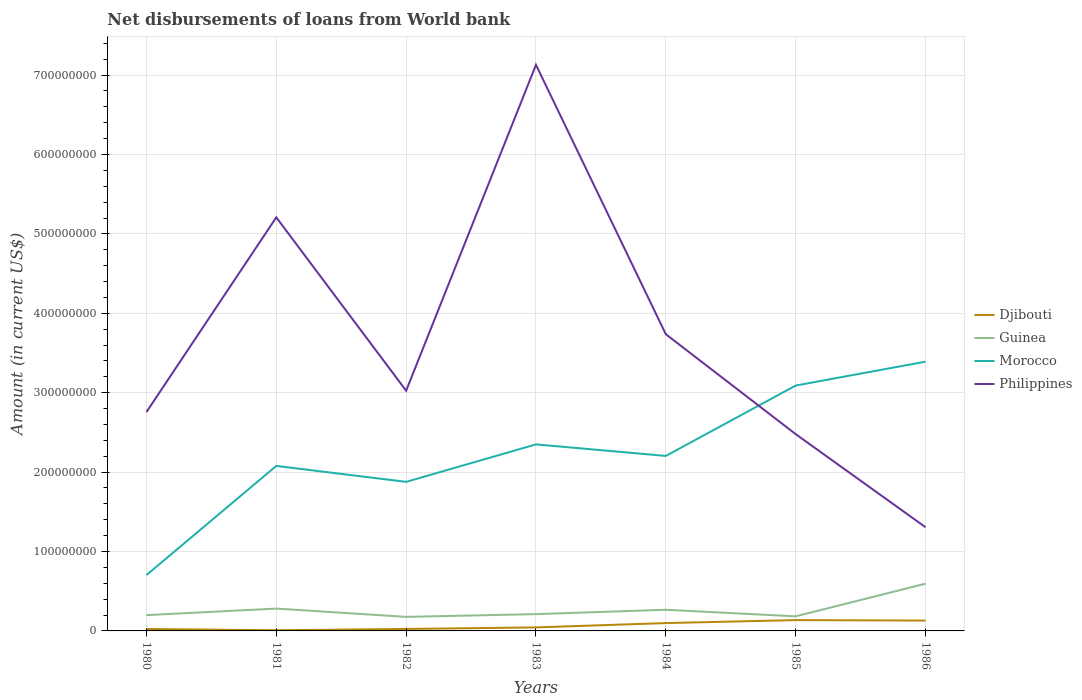How many different coloured lines are there?
Your response must be concise. 4. Is the number of lines equal to the number of legend labels?
Provide a succinct answer. Yes. Across all years, what is the maximum amount of loan disbursed from World Bank in Morocco?
Give a very brief answer. 7.03e+07. What is the total amount of loan disbursed from World Bank in Guinea in the graph?
Ensure brevity in your answer.  2.80e+06. What is the difference between the highest and the second highest amount of loan disbursed from World Bank in Djibouti?
Provide a short and direct response. 1.28e+07. What is the difference between the highest and the lowest amount of loan disbursed from World Bank in Philippines?
Offer a very short reply. 3. Is the amount of loan disbursed from World Bank in Philippines strictly greater than the amount of loan disbursed from World Bank in Guinea over the years?
Your response must be concise. No. How many years are there in the graph?
Make the answer very short. 7. What is the difference between two consecutive major ticks on the Y-axis?
Your response must be concise. 1.00e+08. Are the values on the major ticks of Y-axis written in scientific E-notation?
Your answer should be very brief. No. Does the graph contain any zero values?
Keep it short and to the point. No. Does the graph contain grids?
Ensure brevity in your answer.  Yes. Where does the legend appear in the graph?
Ensure brevity in your answer.  Center right. How many legend labels are there?
Your response must be concise. 4. How are the legend labels stacked?
Keep it short and to the point. Vertical. What is the title of the graph?
Keep it short and to the point. Net disbursements of loans from World bank. What is the Amount (in current US$) of Djibouti in 1980?
Make the answer very short. 2.40e+06. What is the Amount (in current US$) in Guinea in 1980?
Your answer should be very brief. 1.99e+07. What is the Amount (in current US$) in Morocco in 1980?
Offer a terse response. 7.03e+07. What is the Amount (in current US$) of Philippines in 1980?
Keep it short and to the point. 2.76e+08. What is the Amount (in current US$) of Djibouti in 1981?
Provide a succinct answer. 8.20e+05. What is the Amount (in current US$) of Guinea in 1981?
Your answer should be compact. 2.81e+07. What is the Amount (in current US$) in Morocco in 1981?
Make the answer very short. 2.08e+08. What is the Amount (in current US$) in Philippines in 1981?
Your answer should be very brief. 5.21e+08. What is the Amount (in current US$) of Djibouti in 1982?
Your response must be concise. 2.48e+06. What is the Amount (in current US$) of Guinea in 1982?
Keep it short and to the point. 1.77e+07. What is the Amount (in current US$) in Morocco in 1982?
Provide a short and direct response. 1.88e+08. What is the Amount (in current US$) of Philippines in 1982?
Offer a terse response. 3.03e+08. What is the Amount (in current US$) of Djibouti in 1983?
Your answer should be compact. 4.42e+06. What is the Amount (in current US$) in Guinea in 1983?
Offer a terse response. 2.11e+07. What is the Amount (in current US$) in Morocco in 1983?
Your answer should be compact. 2.35e+08. What is the Amount (in current US$) of Philippines in 1983?
Provide a succinct answer. 7.13e+08. What is the Amount (in current US$) in Djibouti in 1984?
Provide a succinct answer. 9.88e+06. What is the Amount (in current US$) of Guinea in 1984?
Provide a succinct answer. 2.66e+07. What is the Amount (in current US$) of Morocco in 1984?
Keep it short and to the point. 2.20e+08. What is the Amount (in current US$) in Philippines in 1984?
Provide a short and direct response. 3.74e+08. What is the Amount (in current US$) of Djibouti in 1985?
Ensure brevity in your answer.  1.36e+07. What is the Amount (in current US$) of Guinea in 1985?
Keep it short and to the point. 1.84e+07. What is the Amount (in current US$) of Morocco in 1985?
Your response must be concise. 3.09e+08. What is the Amount (in current US$) of Philippines in 1985?
Your answer should be very brief. 2.48e+08. What is the Amount (in current US$) in Djibouti in 1986?
Keep it short and to the point. 1.30e+07. What is the Amount (in current US$) of Guinea in 1986?
Ensure brevity in your answer.  5.95e+07. What is the Amount (in current US$) in Morocco in 1986?
Give a very brief answer. 3.39e+08. What is the Amount (in current US$) in Philippines in 1986?
Offer a very short reply. 1.31e+08. Across all years, what is the maximum Amount (in current US$) of Djibouti?
Offer a very short reply. 1.36e+07. Across all years, what is the maximum Amount (in current US$) of Guinea?
Your answer should be very brief. 5.95e+07. Across all years, what is the maximum Amount (in current US$) of Morocco?
Offer a very short reply. 3.39e+08. Across all years, what is the maximum Amount (in current US$) in Philippines?
Your answer should be compact. 7.13e+08. Across all years, what is the minimum Amount (in current US$) in Djibouti?
Ensure brevity in your answer.  8.20e+05. Across all years, what is the minimum Amount (in current US$) in Guinea?
Provide a short and direct response. 1.77e+07. Across all years, what is the minimum Amount (in current US$) of Morocco?
Your answer should be very brief. 7.03e+07. Across all years, what is the minimum Amount (in current US$) of Philippines?
Your response must be concise. 1.31e+08. What is the total Amount (in current US$) of Djibouti in the graph?
Your answer should be compact. 4.67e+07. What is the total Amount (in current US$) in Guinea in the graph?
Keep it short and to the point. 1.91e+08. What is the total Amount (in current US$) in Morocco in the graph?
Offer a terse response. 1.57e+09. What is the total Amount (in current US$) in Philippines in the graph?
Provide a short and direct response. 2.56e+09. What is the difference between the Amount (in current US$) of Djibouti in 1980 and that in 1981?
Keep it short and to the point. 1.58e+06. What is the difference between the Amount (in current US$) in Guinea in 1980 and that in 1981?
Your answer should be compact. -8.24e+06. What is the difference between the Amount (in current US$) in Morocco in 1980 and that in 1981?
Keep it short and to the point. -1.37e+08. What is the difference between the Amount (in current US$) of Philippines in 1980 and that in 1981?
Make the answer very short. -2.45e+08. What is the difference between the Amount (in current US$) in Djibouti in 1980 and that in 1982?
Your response must be concise. -8.30e+04. What is the difference between the Amount (in current US$) in Guinea in 1980 and that in 1982?
Your answer should be very brief. 2.21e+06. What is the difference between the Amount (in current US$) of Morocco in 1980 and that in 1982?
Your answer should be very brief. -1.17e+08. What is the difference between the Amount (in current US$) in Philippines in 1980 and that in 1982?
Your answer should be very brief. -2.69e+07. What is the difference between the Amount (in current US$) in Djibouti in 1980 and that in 1983?
Your answer should be compact. -2.02e+06. What is the difference between the Amount (in current US$) in Guinea in 1980 and that in 1983?
Make the answer very short. -1.24e+06. What is the difference between the Amount (in current US$) of Morocco in 1980 and that in 1983?
Your answer should be compact. -1.65e+08. What is the difference between the Amount (in current US$) of Philippines in 1980 and that in 1983?
Give a very brief answer. -4.37e+08. What is the difference between the Amount (in current US$) in Djibouti in 1980 and that in 1984?
Keep it short and to the point. -7.48e+06. What is the difference between the Amount (in current US$) in Guinea in 1980 and that in 1984?
Keep it short and to the point. -6.73e+06. What is the difference between the Amount (in current US$) in Morocco in 1980 and that in 1984?
Your response must be concise. -1.50e+08. What is the difference between the Amount (in current US$) of Philippines in 1980 and that in 1984?
Your answer should be compact. -9.80e+07. What is the difference between the Amount (in current US$) in Djibouti in 1980 and that in 1985?
Offer a very short reply. -1.12e+07. What is the difference between the Amount (in current US$) in Guinea in 1980 and that in 1985?
Provide a short and direct response. 1.55e+06. What is the difference between the Amount (in current US$) in Morocco in 1980 and that in 1985?
Make the answer very short. -2.39e+08. What is the difference between the Amount (in current US$) of Philippines in 1980 and that in 1985?
Keep it short and to the point. 2.78e+07. What is the difference between the Amount (in current US$) of Djibouti in 1980 and that in 1986?
Your answer should be very brief. -1.06e+07. What is the difference between the Amount (in current US$) of Guinea in 1980 and that in 1986?
Keep it short and to the point. -3.96e+07. What is the difference between the Amount (in current US$) in Morocco in 1980 and that in 1986?
Provide a succinct answer. -2.69e+08. What is the difference between the Amount (in current US$) of Philippines in 1980 and that in 1986?
Offer a terse response. 1.45e+08. What is the difference between the Amount (in current US$) in Djibouti in 1981 and that in 1982?
Offer a very short reply. -1.66e+06. What is the difference between the Amount (in current US$) of Guinea in 1981 and that in 1982?
Your answer should be very brief. 1.04e+07. What is the difference between the Amount (in current US$) in Morocco in 1981 and that in 1982?
Provide a succinct answer. 2.01e+07. What is the difference between the Amount (in current US$) of Philippines in 1981 and that in 1982?
Provide a short and direct response. 2.18e+08. What is the difference between the Amount (in current US$) in Djibouti in 1981 and that in 1983?
Your response must be concise. -3.60e+06. What is the difference between the Amount (in current US$) in Guinea in 1981 and that in 1983?
Provide a short and direct response. 7.00e+06. What is the difference between the Amount (in current US$) of Morocco in 1981 and that in 1983?
Ensure brevity in your answer.  -2.71e+07. What is the difference between the Amount (in current US$) in Philippines in 1981 and that in 1983?
Offer a terse response. -1.92e+08. What is the difference between the Amount (in current US$) of Djibouti in 1981 and that in 1984?
Offer a very short reply. -9.06e+06. What is the difference between the Amount (in current US$) of Guinea in 1981 and that in 1984?
Make the answer very short. 1.51e+06. What is the difference between the Amount (in current US$) of Morocco in 1981 and that in 1984?
Your answer should be very brief. -1.26e+07. What is the difference between the Amount (in current US$) of Philippines in 1981 and that in 1984?
Your answer should be compact. 1.47e+08. What is the difference between the Amount (in current US$) in Djibouti in 1981 and that in 1985?
Provide a short and direct response. -1.28e+07. What is the difference between the Amount (in current US$) in Guinea in 1981 and that in 1985?
Give a very brief answer. 9.79e+06. What is the difference between the Amount (in current US$) in Morocco in 1981 and that in 1985?
Offer a terse response. -1.01e+08. What is the difference between the Amount (in current US$) of Philippines in 1981 and that in 1985?
Provide a succinct answer. 2.73e+08. What is the difference between the Amount (in current US$) of Djibouti in 1981 and that in 1986?
Keep it short and to the point. -1.22e+07. What is the difference between the Amount (in current US$) in Guinea in 1981 and that in 1986?
Ensure brevity in your answer.  -3.14e+07. What is the difference between the Amount (in current US$) in Morocco in 1981 and that in 1986?
Your response must be concise. -1.31e+08. What is the difference between the Amount (in current US$) of Philippines in 1981 and that in 1986?
Make the answer very short. 3.90e+08. What is the difference between the Amount (in current US$) in Djibouti in 1982 and that in 1983?
Ensure brevity in your answer.  -1.94e+06. What is the difference between the Amount (in current US$) of Guinea in 1982 and that in 1983?
Provide a succinct answer. -3.45e+06. What is the difference between the Amount (in current US$) in Morocco in 1982 and that in 1983?
Offer a terse response. -4.72e+07. What is the difference between the Amount (in current US$) of Philippines in 1982 and that in 1983?
Keep it short and to the point. -4.10e+08. What is the difference between the Amount (in current US$) in Djibouti in 1982 and that in 1984?
Make the answer very short. -7.40e+06. What is the difference between the Amount (in current US$) of Guinea in 1982 and that in 1984?
Your answer should be compact. -8.94e+06. What is the difference between the Amount (in current US$) in Morocco in 1982 and that in 1984?
Make the answer very short. -3.27e+07. What is the difference between the Amount (in current US$) of Philippines in 1982 and that in 1984?
Provide a succinct answer. -7.11e+07. What is the difference between the Amount (in current US$) of Djibouti in 1982 and that in 1985?
Provide a short and direct response. -1.11e+07. What is the difference between the Amount (in current US$) in Guinea in 1982 and that in 1985?
Offer a very short reply. -6.57e+05. What is the difference between the Amount (in current US$) of Morocco in 1982 and that in 1985?
Provide a succinct answer. -1.21e+08. What is the difference between the Amount (in current US$) in Philippines in 1982 and that in 1985?
Ensure brevity in your answer.  5.47e+07. What is the difference between the Amount (in current US$) of Djibouti in 1982 and that in 1986?
Ensure brevity in your answer.  -1.06e+07. What is the difference between the Amount (in current US$) of Guinea in 1982 and that in 1986?
Ensure brevity in your answer.  -4.18e+07. What is the difference between the Amount (in current US$) in Morocco in 1982 and that in 1986?
Your response must be concise. -1.51e+08. What is the difference between the Amount (in current US$) of Philippines in 1982 and that in 1986?
Provide a short and direct response. 1.72e+08. What is the difference between the Amount (in current US$) of Djibouti in 1983 and that in 1984?
Provide a short and direct response. -5.46e+06. What is the difference between the Amount (in current US$) in Guinea in 1983 and that in 1984?
Your response must be concise. -5.49e+06. What is the difference between the Amount (in current US$) in Morocco in 1983 and that in 1984?
Offer a very short reply. 1.45e+07. What is the difference between the Amount (in current US$) in Philippines in 1983 and that in 1984?
Offer a very short reply. 3.39e+08. What is the difference between the Amount (in current US$) of Djibouti in 1983 and that in 1985?
Your response must be concise. -9.21e+06. What is the difference between the Amount (in current US$) in Guinea in 1983 and that in 1985?
Ensure brevity in your answer.  2.80e+06. What is the difference between the Amount (in current US$) of Morocco in 1983 and that in 1985?
Give a very brief answer. -7.41e+07. What is the difference between the Amount (in current US$) of Philippines in 1983 and that in 1985?
Make the answer very short. 4.65e+08. What is the difference between the Amount (in current US$) in Djibouti in 1983 and that in 1986?
Your answer should be compact. -8.62e+06. What is the difference between the Amount (in current US$) of Guinea in 1983 and that in 1986?
Give a very brief answer. -3.84e+07. What is the difference between the Amount (in current US$) of Morocco in 1983 and that in 1986?
Keep it short and to the point. -1.04e+08. What is the difference between the Amount (in current US$) in Philippines in 1983 and that in 1986?
Provide a succinct answer. 5.82e+08. What is the difference between the Amount (in current US$) of Djibouti in 1984 and that in 1985?
Your answer should be compact. -3.75e+06. What is the difference between the Amount (in current US$) in Guinea in 1984 and that in 1985?
Your response must be concise. 8.29e+06. What is the difference between the Amount (in current US$) in Morocco in 1984 and that in 1985?
Your answer should be very brief. -8.86e+07. What is the difference between the Amount (in current US$) in Philippines in 1984 and that in 1985?
Your answer should be compact. 1.26e+08. What is the difference between the Amount (in current US$) in Djibouti in 1984 and that in 1986?
Ensure brevity in your answer.  -3.16e+06. What is the difference between the Amount (in current US$) of Guinea in 1984 and that in 1986?
Your response must be concise. -3.29e+07. What is the difference between the Amount (in current US$) of Morocco in 1984 and that in 1986?
Your response must be concise. -1.19e+08. What is the difference between the Amount (in current US$) in Philippines in 1984 and that in 1986?
Your answer should be very brief. 2.43e+08. What is the difference between the Amount (in current US$) in Djibouti in 1985 and that in 1986?
Your answer should be very brief. 5.93e+05. What is the difference between the Amount (in current US$) of Guinea in 1985 and that in 1986?
Keep it short and to the point. -4.12e+07. What is the difference between the Amount (in current US$) of Morocco in 1985 and that in 1986?
Ensure brevity in your answer.  -3.01e+07. What is the difference between the Amount (in current US$) of Philippines in 1985 and that in 1986?
Provide a succinct answer. 1.17e+08. What is the difference between the Amount (in current US$) of Djibouti in 1980 and the Amount (in current US$) of Guinea in 1981?
Make the answer very short. -2.57e+07. What is the difference between the Amount (in current US$) in Djibouti in 1980 and the Amount (in current US$) in Morocco in 1981?
Your answer should be very brief. -2.05e+08. What is the difference between the Amount (in current US$) in Djibouti in 1980 and the Amount (in current US$) in Philippines in 1981?
Provide a short and direct response. -5.18e+08. What is the difference between the Amount (in current US$) in Guinea in 1980 and the Amount (in current US$) in Morocco in 1981?
Offer a terse response. -1.88e+08. What is the difference between the Amount (in current US$) in Guinea in 1980 and the Amount (in current US$) in Philippines in 1981?
Make the answer very short. -5.01e+08. What is the difference between the Amount (in current US$) of Morocco in 1980 and the Amount (in current US$) of Philippines in 1981?
Your response must be concise. -4.50e+08. What is the difference between the Amount (in current US$) of Djibouti in 1980 and the Amount (in current US$) of Guinea in 1982?
Provide a succinct answer. -1.53e+07. What is the difference between the Amount (in current US$) in Djibouti in 1980 and the Amount (in current US$) in Morocco in 1982?
Your response must be concise. -1.85e+08. What is the difference between the Amount (in current US$) of Djibouti in 1980 and the Amount (in current US$) of Philippines in 1982?
Your answer should be compact. -3.00e+08. What is the difference between the Amount (in current US$) of Guinea in 1980 and the Amount (in current US$) of Morocco in 1982?
Offer a very short reply. -1.68e+08. What is the difference between the Amount (in current US$) in Guinea in 1980 and the Amount (in current US$) in Philippines in 1982?
Your answer should be compact. -2.83e+08. What is the difference between the Amount (in current US$) in Morocco in 1980 and the Amount (in current US$) in Philippines in 1982?
Provide a succinct answer. -2.32e+08. What is the difference between the Amount (in current US$) in Djibouti in 1980 and the Amount (in current US$) in Guinea in 1983?
Keep it short and to the point. -1.88e+07. What is the difference between the Amount (in current US$) in Djibouti in 1980 and the Amount (in current US$) in Morocco in 1983?
Provide a succinct answer. -2.33e+08. What is the difference between the Amount (in current US$) of Djibouti in 1980 and the Amount (in current US$) of Philippines in 1983?
Offer a terse response. -7.11e+08. What is the difference between the Amount (in current US$) of Guinea in 1980 and the Amount (in current US$) of Morocco in 1983?
Your answer should be compact. -2.15e+08. What is the difference between the Amount (in current US$) in Guinea in 1980 and the Amount (in current US$) in Philippines in 1983?
Provide a short and direct response. -6.93e+08. What is the difference between the Amount (in current US$) in Morocco in 1980 and the Amount (in current US$) in Philippines in 1983?
Make the answer very short. -6.43e+08. What is the difference between the Amount (in current US$) of Djibouti in 1980 and the Amount (in current US$) of Guinea in 1984?
Your answer should be compact. -2.42e+07. What is the difference between the Amount (in current US$) in Djibouti in 1980 and the Amount (in current US$) in Morocco in 1984?
Offer a terse response. -2.18e+08. What is the difference between the Amount (in current US$) of Djibouti in 1980 and the Amount (in current US$) of Philippines in 1984?
Your response must be concise. -3.71e+08. What is the difference between the Amount (in current US$) of Guinea in 1980 and the Amount (in current US$) of Morocco in 1984?
Make the answer very short. -2.00e+08. What is the difference between the Amount (in current US$) in Guinea in 1980 and the Amount (in current US$) in Philippines in 1984?
Your answer should be very brief. -3.54e+08. What is the difference between the Amount (in current US$) of Morocco in 1980 and the Amount (in current US$) of Philippines in 1984?
Your answer should be very brief. -3.03e+08. What is the difference between the Amount (in current US$) of Djibouti in 1980 and the Amount (in current US$) of Guinea in 1985?
Your answer should be very brief. -1.60e+07. What is the difference between the Amount (in current US$) in Djibouti in 1980 and the Amount (in current US$) in Morocco in 1985?
Your answer should be very brief. -3.07e+08. What is the difference between the Amount (in current US$) of Djibouti in 1980 and the Amount (in current US$) of Philippines in 1985?
Your answer should be very brief. -2.45e+08. What is the difference between the Amount (in current US$) in Guinea in 1980 and the Amount (in current US$) in Morocco in 1985?
Keep it short and to the point. -2.89e+08. What is the difference between the Amount (in current US$) in Guinea in 1980 and the Amount (in current US$) in Philippines in 1985?
Give a very brief answer. -2.28e+08. What is the difference between the Amount (in current US$) of Morocco in 1980 and the Amount (in current US$) of Philippines in 1985?
Offer a terse response. -1.78e+08. What is the difference between the Amount (in current US$) in Djibouti in 1980 and the Amount (in current US$) in Guinea in 1986?
Keep it short and to the point. -5.71e+07. What is the difference between the Amount (in current US$) of Djibouti in 1980 and the Amount (in current US$) of Morocco in 1986?
Make the answer very short. -3.37e+08. What is the difference between the Amount (in current US$) in Djibouti in 1980 and the Amount (in current US$) in Philippines in 1986?
Your response must be concise. -1.28e+08. What is the difference between the Amount (in current US$) in Guinea in 1980 and the Amount (in current US$) in Morocco in 1986?
Your response must be concise. -3.19e+08. What is the difference between the Amount (in current US$) in Guinea in 1980 and the Amount (in current US$) in Philippines in 1986?
Offer a terse response. -1.11e+08. What is the difference between the Amount (in current US$) in Morocco in 1980 and the Amount (in current US$) in Philippines in 1986?
Offer a terse response. -6.03e+07. What is the difference between the Amount (in current US$) of Djibouti in 1981 and the Amount (in current US$) of Guinea in 1982?
Keep it short and to the point. -1.69e+07. What is the difference between the Amount (in current US$) in Djibouti in 1981 and the Amount (in current US$) in Morocco in 1982?
Your answer should be very brief. -1.87e+08. What is the difference between the Amount (in current US$) of Djibouti in 1981 and the Amount (in current US$) of Philippines in 1982?
Your answer should be compact. -3.02e+08. What is the difference between the Amount (in current US$) in Guinea in 1981 and the Amount (in current US$) in Morocco in 1982?
Keep it short and to the point. -1.60e+08. What is the difference between the Amount (in current US$) of Guinea in 1981 and the Amount (in current US$) of Philippines in 1982?
Offer a very short reply. -2.74e+08. What is the difference between the Amount (in current US$) in Morocco in 1981 and the Amount (in current US$) in Philippines in 1982?
Offer a terse response. -9.47e+07. What is the difference between the Amount (in current US$) of Djibouti in 1981 and the Amount (in current US$) of Guinea in 1983?
Make the answer very short. -2.03e+07. What is the difference between the Amount (in current US$) in Djibouti in 1981 and the Amount (in current US$) in Morocco in 1983?
Give a very brief answer. -2.34e+08. What is the difference between the Amount (in current US$) in Djibouti in 1981 and the Amount (in current US$) in Philippines in 1983?
Your response must be concise. -7.12e+08. What is the difference between the Amount (in current US$) in Guinea in 1981 and the Amount (in current US$) in Morocco in 1983?
Your answer should be very brief. -2.07e+08. What is the difference between the Amount (in current US$) in Guinea in 1981 and the Amount (in current US$) in Philippines in 1983?
Ensure brevity in your answer.  -6.85e+08. What is the difference between the Amount (in current US$) in Morocco in 1981 and the Amount (in current US$) in Philippines in 1983?
Provide a succinct answer. -5.05e+08. What is the difference between the Amount (in current US$) in Djibouti in 1981 and the Amount (in current US$) in Guinea in 1984?
Offer a terse response. -2.58e+07. What is the difference between the Amount (in current US$) of Djibouti in 1981 and the Amount (in current US$) of Morocco in 1984?
Your answer should be compact. -2.20e+08. What is the difference between the Amount (in current US$) of Djibouti in 1981 and the Amount (in current US$) of Philippines in 1984?
Keep it short and to the point. -3.73e+08. What is the difference between the Amount (in current US$) of Guinea in 1981 and the Amount (in current US$) of Morocco in 1984?
Keep it short and to the point. -1.92e+08. What is the difference between the Amount (in current US$) of Guinea in 1981 and the Amount (in current US$) of Philippines in 1984?
Give a very brief answer. -3.46e+08. What is the difference between the Amount (in current US$) of Morocco in 1981 and the Amount (in current US$) of Philippines in 1984?
Offer a very short reply. -1.66e+08. What is the difference between the Amount (in current US$) of Djibouti in 1981 and the Amount (in current US$) of Guinea in 1985?
Your answer should be compact. -1.75e+07. What is the difference between the Amount (in current US$) of Djibouti in 1981 and the Amount (in current US$) of Morocco in 1985?
Your answer should be very brief. -3.08e+08. What is the difference between the Amount (in current US$) of Djibouti in 1981 and the Amount (in current US$) of Philippines in 1985?
Provide a short and direct response. -2.47e+08. What is the difference between the Amount (in current US$) of Guinea in 1981 and the Amount (in current US$) of Morocco in 1985?
Keep it short and to the point. -2.81e+08. What is the difference between the Amount (in current US$) in Guinea in 1981 and the Amount (in current US$) in Philippines in 1985?
Your answer should be compact. -2.20e+08. What is the difference between the Amount (in current US$) in Morocco in 1981 and the Amount (in current US$) in Philippines in 1985?
Ensure brevity in your answer.  -4.01e+07. What is the difference between the Amount (in current US$) of Djibouti in 1981 and the Amount (in current US$) of Guinea in 1986?
Your answer should be compact. -5.87e+07. What is the difference between the Amount (in current US$) in Djibouti in 1981 and the Amount (in current US$) in Morocco in 1986?
Provide a short and direct response. -3.38e+08. What is the difference between the Amount (in current US$) in Djibouti in 1981 and the Amount (in current US$) in Philippines in 1986?
Your answer should be very brief. -1.30e+08. What is the difference between the Amount (in current US$) in Guinea in 1981 and the Amount (in current US$) in Morocco in 1986?
Provide a succinct answer. -3.11e+08. What is the difference between the Amount (in current US$) in Guinea in 1981 and the Amount (in current US$) in Philippines in 1986?
Offer a terse response. -1.02e+08. What is the difference between the Amount (in current US$) of Morocco in 1981 and the Amount (in current US$) of Philippines in 1986?
Give a very brief answer. 7.72e+07. What is the difference between the Amount (in current US$) of Djibouti in 1982 and the Amount (in current US$) of Guinea in 1983?
Provide a short and direct response. -1.87e+07. What is the difference between the Amount (in current US$) of Djibouti in 1982 and the Amount (in current US$) of Morocco in 1983?
Offer a very short reply. -2.32e+08. What is the difference between the Amount (in current US$) of Djibouti in 1982 and the Amount (in current US$) of Philippines in 1983?
Your answer should be compact. -7.10e+08. What is the difference between the Amount (in current US$) of Guinea in 1982 and the Amount (in current US$) of Morocco in 1983?
Your answer should be compact. -2.17e+08. What is the difference between the Amount (in current US$) of Guinea in 1982 and the Amount (in current US$) of Philippines in 1983?
Provide a succinct answer. -6.95e+08. What is the difference between the Amount (in current US$) in Morocco in 1982 and the Amount (in current US$) in Philippines in 1983?
Provide a succinct answer. -5.25e+08. What is the difference between the Amount (in current US$) in Djibouti in 1982 and the Amount (in current US$) in Guinea in 1984?
Your answer should be very brief. -2.42e+07. What is the difference between the Amount (in current US$) in Djibouti in 1982 and the Amount (in current US$) in Morocco in 1984?
Provide a short and direct response. -2.18e+08. What is the difference between the Amount (in current US$) of Djibouti in 1982 and the Amount (in current US$) of Philippines in 1984?
Your answer should be very brief. -3.71e+08. What is the difference between the Amount (in current US$) of Guinea in 1982 and the Amount (in current US$) of Morocco in 1984?
Make the answer very short. -2.03e+08. What is the difference between the Amount (in current US$) of Guinea in 1982 and the Amount (in current US$) of Philippines in 1984?
Offer a very short reply. -3.56e+08. What is the difference between the Amount (in current US$) in Morocco in 1982 and the Amount (in current US$) in Philippines in 1984?
Your response must be concise. -1.86e+08. What is the difference between the Amount (in current US$) of Djibouti in 1982 and the Amount (in current US$) of Guinea in 1985?
Your answer should be very brief. -1.59e+07. What is the difference between the Amount (in current US$) of Djibouti in 1982 and the Amount (in current US$) of Morocco in 1985?
Keep it short and to the point. -3.07e+08. What is the difference between the Amount (in current US$) in Djibouti in 1982 and the Amount (in current US$) in Philippines in 1985?
Your answer should be very brief. -2.45e+08. What is the difference between the Amount (in current US$) in Guinea in 1982 and the Amount (in current US$) in Morocco in 1985?
Ensure brevity in your answer.  -2.91e+08. What is the difference between the Amount (in current US$) of Guinea in 1982 and the Amount (in current US$) of Philippines in 1985?
Your answer should be very brief. -2.30e+08. What is the difference between the Amount (in current US$) of Morocco in 1982 and the Amount (in current US$) of Philippines in 1985?
Your response must be concise. -6.01e+07. What is the difference between the Amount (in current US$) of Djibouti in 1982 and the Amount (in current US$) of Guinea in 1986?
Give a very brief answer. -5.70e+07. What is the difference between the Amount (in current US$) of Djibouti in 1982 and the Amount (in current US$) of Morocco in 1986?
Keep it short and to the point. -3.37e+08. What is the difference between the Amount (in current US$) in Djibouti in 1982 and the Amount (in current US$) in Philippines in 1986?
Offer a terse response. -1.28e+08. What is the difference between the Amount (in current US$) in Guinea in 1982 and the Amount (in current US$) in Morocco in 1986?
Offer a very short reply. -3.21e+08. What is the difference between the Amount (in current US$) in Guinea in 1982 and the Amount (in current US$) in Philippines in 1986?
Keep it short and to the point. -1.13e+08. What is the difference between the Amount (in current US$) of Morocco in 1982 and the Amount (in current US$) of Philippines in 1986?
Your answer should be very brief. 5.71e+07. What is the difference between the Amount (in current US$) in Djibouti in 1983 and the Amount (in current US$) in Guinea in 1984?
Give a very brief answer. -2.22e+07. What is the difference between the Amount (in current US$) in Djibouti in 1983 and the Amount (in current US$) in Morocco in 1984?
Provide a succinct answer. -2.16e+08. What is the difference between the Amount (in current US$) of Djibouti in 1983 and the Amount (in current US$) of Philippines in 1984?
Offer a very short reply. -3.69e+08. What is the difference between the Amount (in current US$) in Guinea in 1983 and the Amount (in current US$) in Morocco in 1984?
Ensure brevity in your answer.  -1.99e+08. What is the difference between the Amount (in current US$) in Guinea in 1983 and the Amount (in current US$) in Philippines in 1984?
Ensure brevity in your answer.  -3.53e+08. What is the difference between the Amount (in current US$) in Morocco in 1983 and the Amount (in current US$) in Philippines in 1984?
Your answer should be compact. -1.39e+08. What is the difference between the Amount (in current US$) in Djibouti in 1983 and the Amount (in current US$) in Guinea in 1985?
Make the answer very short. -1.39e+07. What is the difference between the Amount (in current US$) of Djibouti in 1983 and the Amount (in current US$) of Morocco in 1985?
Give a very brief answer. -3.05e+08. What is the difference between the Amount (in current US$) of Djibouti in 1983 and the Amount (in current US$) of Philippines in 1985?
Your answer should be very brief. -2.43e+08. What is the difference between the Amount (in current US$) in Guinea in 1983 and the Amount (in current US$) in Morocco in 1985?
Your answer should be compact. -2.88e+08. What is the difference between the Amount (in current US$) in Guinea in 1983 and the Amount (in current US$) in Philippines in 1985?
Provide a succinct answer. -2.27e+08. What is the difference between the Amount (in current US$) in Morocco in 1983 and the Amount (in current US$) in Philippines in 1985?
Make the answer very short. -1.29e+07. What is the difference between the Amount (in current US$) of Djibouti in 1983 and the Amount (in current US$) of Guinea in 1986?
Provide a succinct answer. -5.51e+07. What is the difference between the Amount (in current US$) in Djibouti in 1983 and the Amount (in current US$) in Morocco in 1986?
Offer a very short reply. -3.35e+08. What is the difference between the Amount (in current US$) in Djibouti in 1983 and the Amount (in current US$) in Philippines in 1986?
Offer a terse response. -1.26e+08. What is the difference between the Amount (in current US$) in Guinea in 1983 and the Amount (in current US$) in Morocco in 1986?
Offer a terse response. -3.18e+08. What is the difference between the Amount (in current US$) of Guinea in 1983 and the Amount (in current US$) of Philippines in 1986?
Your response must be concise. -1.09e+08. What is the difference between the Amount (in current US$) in Morocco in 1983 and the Amount (in current US$) in Philippines in 1986?
Offer a very short reply. 1.04e+08. What is the difference between the Amount (in current US$) of Djibouti in 1984 and the Amount (in current US$) of Guinea in 1985?
Keep it short and to the point. -8.48e+06. What is the difference between the Amount (in current US$) of Djibouti in 1984 and the Amount (in current US$) of Morocco in 1985?
Provide a short and direct response. -2.99e+08. What is the difference between the Amount (in current US$) in Djibouti in 1984 and the Amount (in current US$) in Philippines in 1985?
Make the answer very short. -2.38e+08. What is the difference between the Amount (in current US$) in Guinea in 1984 and the Amount (in current US$) in Morocco in 1985?
Give a very brief answer. -2.82e+08. What is the difference between the Amount (in current US$) in Guinea in 1984 and the Amount (in current US$) in Philippines in 1985?
Keep it short and to the point. -2.21e+08. What is the difference between the Amount (in current US$) in Morocco in 1984 and the Amount (in current US$) in Philippines in 1985?
Provide a short and direct response. -2.75e+07. What is the difference between the Amount (in current US$) in Djibouti in 1984 and the Amount (in current US$) in Guinea in 1986?
Keep it short and to the point. -4.96e+07. What is the difference between the Amount (in current US$) of Djibouti in 1984 and the Amount (in current US$) of Morocco in 1986?
Offer a very short reply. -3.29e+08. What is the difference between the Amount (in current US$) of Djibouti in 1984 and the Amount (in current US$) of Philippines in 1986?
Keep it short and to the point. -1.21e+08. What is the difference between the Amount (in current US$) of Guinea in 1984 and the Amount (in current US$) of Morocco in 1986?
Keep it short and to the point. -3.12e+08. What is the difference between the Amount (in current US$) of Guinea in 1984 and the Amount (in current US$) of Philippines in 1986?
Provide a succinct answer. -1.04e+08. What is the difference between the Amount (in current US$) in Morocco in 1984 and the Amount (in current US$) in Philippines in 1986?
Your response must be concise. 8.98e+07. What is the difference between the Amount (in current US$) of Djibouti in 1985 and the Amount (in current US$) of Guinea in 1986?
Your answer should be compact. -4.59e+07. What is the difference between the Amount (in current US$) of Djibouti in 1985 and the Amount (in current US$) of Morocco in 1986?
Ensure brevity in your answer.  -3.25e+08. What is the difference between the Amount (in current US$) of Djibouti in 1985 and the Amount (in current US$) of Philippines in 1986?
Offer a very short reply. -1.17e+08. What is the difference between the Amount (in current US$) in Guinea in 1985 and the Amount (in current US$) in Morocco in 1986?
Offer a very short reply. -3.21e+08. What is the difference between the Amount (in current US$) of Guinea in 1985 and the Amount (in current US$) of Philippines in 1986?
Ensure brevity in your answer.  -1.12e+08. What is the difference between the Amount (in current US$) in Morocco in 1985 and the Amount (in current US$) in Philippines in 1986?
Your answer should be compact. 1.78e+08. What is the average Amount (in current US$) in Djibouti per year?
Offer a terse response. 6.66e+06. What is the average Amount (in current US$) of Guinea per year?
Your answer should be compact. 2.73e+07. What is the average Amount (in current US$) in Morocco per year?
Make the answer very short. 2.24e+08. What is the average Amount (in current US$) of Philippines per year?
Keep it short and to the point. 3.66e+08. In the year 1980, what is the difference between the Amount (in current US$) in Djibouti and Amount (in current US$) in Guinea?
Keep it short and to the point. -1.75e+07. In the year 1980, what is the difference between the Amount (in current US$) in Djibouti and Amount (in current US$) in Morocco?
Provide a short and direct response. -6.79e+07. In the year 1980, what is the difference between the Amount (in current US$) of Djibouti and Amount (in current US$) of Philippines?
Provide a short and direct response. -2.73e+08. In the year 1980, what is the difference between the Amount (in current US$) in Guinea and Amount (in current US$) in Morocco?
Give a very brief answer. -5.04e+07. In the year 1980, what is the difference between the Amount (in current US$) in Guinea and Amount (in current US$) in Philippines?
Give a very brief answer. -2.56e+08. In the year 1980, what is the difference between the Amount (in current US$) of Morocco and Amount (in current US$) of Philippines?
Provide a short and direct response. -2.05e+08. In the year 1981, what is the difference between the Amount (in current US$) of Djibouti and Amount (in current US$) of Guinea?
Your response must be concise. -2.73e+07. In the year 1981, what is the difference between the Amount (in current US$) of Djibouti and Amount (in current US$) of Morocco?
Provide a short and direct response. -2.07e+08. In the year 1981, what is the difference between the Amount (in current US$) in Djibouti and Amount (in current US$) in Philippines?
Ensure brevity in your answer.  -5.20e+08. In the year 1981, what is the difference between the Amount (in current US$) of Guinea and Amount (in current US$) of Morocco?
Give a very brief answer. -1.80e+08. In the year 1981, what is the difference between the Amount (in current US$) of Guinea and Amount (in current US$) of Philippines?
Your answer should be compact. -4.93e+08. In the year 1981, what is the difference between the Amount (in current US$) of Morocco and Amount (in current US$) of Philippines?
Offer a terse response. -3.13e+08. In the year 1982, what is the difference between the Amount (in current US$) in Djibouti and Amount (in current US$) in Guinea?
Provide a short and direct response. -1.52e+07. In the year 1982, what is the difference between the Amount (in current US$) of Djibouti and Amount (in current US$) of Morocco?
Your answer should be compact. -1.85e+08. In the year 1982, what is the difference between the Amount (in current US$) in Djibouti and Amount (in current US$) in Philippines?
Your answer should be very brief. -3.00e+08. In the year 1982, what is the difference between the Amount (in current US$) of Guinea and Amount (in current US$) of Morocco?
Your answer should be very brief. -1.70e+08. In the year 1982, what is the difference between the Amount (in current US$) of Guinea and Amount (in current US$) of Philippines?
Keep it short and to the point. -2.85e+08. In the year 1982, what is the difference between the Amount (in current US$) of Morocco and Amount (in current US$) of Philippines?
Your response must be concise. -1.15e+08. In the year 1983, what is the difference between the Amount (in current US$) of Djibouti and Amount (in current US$) of Guinea?
Your answer should be very brief. -1.67e+07. In the year 1983, what is the difference between the Amount (in current US$) of Djibouti and Amount (in current US$) of Morocco?
Your answer should be very brief. -2.30e+08. In the year 1983, what is the difference between the Amount (in current US$) in Djibouti and Amount (in current US$) in Philippines?
Keep it short and to the point. -7.08e+08. In the year 1983, what is the difference between the Amount (in current US$) in Guinea and Amount (in current US$) in Morocco?
Your response must be concise. -2.14e+08. In the year 1983, what is the difference between the Amount (in current US$) in Guinea and Amount (in current US$) in Philippines?
Give a very brief answer. -6.92e+08. In the year 1983, what is the difference between the Amount (in current US$) of Morocco and Amount (in current US$) of Philippines?
Your answer should be compact. -4.78e+08. In the year 1984, what is the difference between the Amount (in current US$) of Djibouti and Amount (in current US$) of Guinea?
Offer a terse response. -1.68e+07. In the year 1984, what is the difference between the Amount (in current US$) of Djibouti and Amount (in current US$) of Morocco?
Your response must be concise. -2.11e+08. In the year 1984, what is the difference between the Amount (in current US$) in Djibouti and Amount (in current US$) in Philippines?
Give a very brief answer. -3.64e+08. In the year 1984, what is the difference between the Amount (in current US$) of Guinea and Amount (in current US$) of Morocco?
Your answer should be very brief. -1.94e+08. In the year 1984, what is the difference between the Amount (in current US$) of Guinea and Amount (in current US$) of Philippines?
Keep it short and to the point. -3.47e+08. In the year 1984, what is the difference between the Amount (in current US$) of Morocco and Amount (in current US$) of Philippines?
Your response must be concise. -1.53e+08. In the year 1985, what is the difference between the Amount (in current US$) in Djibouti and Amount (in current US$) in Guinea?
Offer a very short reply. -4.73e+06. In the year 1985, what is the difference between the Amount (in current US$) of Djibouti and Amount (in current US$) of Morocco?
Give a very brief answer. -2.95e+08. In the year 1985, what is the difference between the Amount (in current US$) in Djibouti and Amount (in current US$) in Philippines?
Your answer should be very brief. -2.34e+08. In the year 1985, what is the difference between the Amount (in current US$) of Guinea and Amount (in current US$) of Morocco?
Your response must be concise. -2.91e+08. In the year 1985, what is the difference between the Amount (in current US$) of Guinea and Amount (in current US$) of Philippines?
Ensure brevity in your answer.  -2.29e+08. In the year 1985, what is the difference between the Amount (in current US$) of Morocco and Amount (in current US$) of Philippines?
Offer a very short reply. 6.11e+07. In the year 1986, what is the difference between the Amount (in current US$) in Djibouti and Amount (in current US$) in Guinea?
Offer a very short reply. -4.65e+07. In the year 1986, what is the difference between the Amount (in current US$) in Djibouti and Amount (in current US$) in Morocco?
Your answer should be compact. -3.26e+08. In the year 1986, what is the difference between the Amount (in current US$) of Djibouti and Amount (in current US$) of Philippines?
Your response must be concise. -1.18e+08. In the year 1986, what is the difference between the Amount (in current US$) of Guinea and Amount (in current US$) of Morocco?
Provide a succinct answer. -2.80e+08. In the year 1986, what is the difference between the Amount (in current US$) in Guinea and Amount (in current US$) in Philippines?
Your response must be concise. -7.11e+07. In the year 1986, what is the difference between the Amount (in current US$) of Morocco and Amount (in current US$) of Philippines?
Give a very brief answer. 2.08e+08. What is the ratio of the Amount (in current US$) of Djibouti in 1980 to that in 1981?
Make the answer very short. 2.92. What is the ratio of the Amount (in current US$) in Guinea in 1980 to that in 1981?
Your response must be concise. 0.71. What is the ratio of the Amount (in current US$) in Morocco in 1980 to that in 1981?
Provide a succinct answer. 0.34. What is the ratio of the Amount (in current US$) of Philippines in 1980 to that in 1981?
Your response must be concise. 0.53. What is the ratio of the Amount (in current US$) in Djibouti in 1980 to that in 1982?
Provide a succinct answer. 0.97. What is the ratio of the Amount (in current US$) of Guinea in 1980 to that in 1982?
Offer a terse response. 1.12. What is the ratio of the Amount (in current US$) in Morocco in 1980 to that in 1982?
Provide a succinct answer. 0.37. What is the ratio of the Amount (in current US$) of Philippines in 1980 to that in 1982?
Your response must be concise. 0.91. What is the ratio of the Amount (in current US$) of Djibouti in 1980 to that in 1983?
Your answer should be compact. 0.54. What is the ratio of the Amount (in current US$) of Guinea in 1980 to that in 1983?
Ensure brevity in your answer.  0.94. What is the ratio of the Amount (in current US$) in Morocco in 1980 to that in 1983?
Make the answer very short. 0.3. What is the ratio of the Amount (in current US$) in Philippines in 1980 to that in 1983?
Make the answer very short. 0.39. What is the ratio of the Amount (in current US$) of Djibouti in 1980 to that in 1984?
Keep it short and to the point. 0.24. What is the ratio of the Amount (in current US$) of Guinea in 1980 to that in 1984?
Make the answer very short. 0.75. What is the ratio of the Amount (in current US$) in Morocco in 1980 to that in 1984?
Offer a very short reply. 0.32. What is the ratio of the Amount (in current US$) in Philippines in 1980 to that in 1984?
Offer a very short reply. 0.74. What is the ratio of the Amount (in current US$) of Djibouti in 1980 to that in 1985?
Your answer should be very brief. 0.18. What is the ratio of the Amount (in current US$) in Guinea in 1980 to that in 1985?
Your answer should be compact. 1.08. What is the ratio of the Amount (in current US$) in Morocco in 1980 to that in 1985?
Keep it short and to the point. 0.23. What is the ratio of the Amount (in current US$) in Philippines in 1980 to that in 1985?
Your response must be concise. 1.11. What is the ratio of the Amount (in current US$) of Djibouti in 1980 to that in 1986?
Your answer should be very brief. 0.18. What is the ratio of the Amount (in current US$) of Guinea in 1980 to that in 1986?
Provide a succinct answer. 0.33. What is the ratio of the Amount (in current US$) of Morocco in 1980 to that in 1986?
Your answer should be very brief. 0.21. What is the ratio of the Amount (in current US$) in Philippines in 1980 to that in 1986?
Your answer should be compact. 2.11. What is the ratio of the Amount (in current US$) of Djibouti in 1981 to that in 1982?
Your answer should be compact. 0.33. What is the ratio of the Amount (in current US$) in Guinea in 1981 to that in 1982?
Offer a very short reply. 1.59. What is the ratio of the Amount (in current US$) of Morocco in 1981 to that in 1982?
Keep it short and to the point. 1.11. What is the ratio of the Amount (in current US$) of Philippines in 1981 to that in 1982?
Offer a terse response. 1.72. What is the ratio of the Amount (in current US$) of Djibouti in 1981 to that in 1983?
Keep it short and to the point. 0.19. What is the ratio of the Amount (in current US$) in Guinea in 1981 to that in 1983?
Offer a very short reply. 1.33. What is the ratio of the Amount (in current US$) in Morocco in 1981 to that in 1983?
Provide a short and direct response. 0.88. What is the ratio of the Amount (in current US$) of Philippines in 1981 to that in 1983?
Ensure brevity in your answer.  0.73. What is the ratio of the Amount (in current US$) of Djibouti in 1981 to that in 1984?
Ensure brevity in your answer.  0.08. What is the ratio of the Amount (in current US$) of Guinea in 1981 to that in 1984?
Offer a very short reply. 1.06. What is the ratio of the Amount (in current US$) of Morocco in 1981 to that in 1984?
Offer a very short reply. 0.94. What is the ratio of the Amount (in current US$) in Philippines in 1981 to that in 1984?
Your answer should be compact. 1.39. What is the ratio of the Amount (in current US$) of Djibouti in 1981 to that in 1985?
Provide a succinct answer. 0.06. What is the ratio of the Amount (in current US$) in Guinea in 1981 to that in 1985?
Offer a terse response. 1.53. What is the ratio of the Amount (in current US$) of Morocco in 1981 to that in 1985?
Your answer should be compact. 0.67. What is the ratio of the Amount (in current US$) of Philippines in 1981 to that in 1985?
Provide a short and direct response. 2.1. What is the ratio of the Amount (in current US$) of Djibouti in 1981 to that in 1986?
Ensure brevity in your answer.  0.06. What is the ratio of the Amount (in current US$) in Guinea in 1981 to that in 1986?
Offer a terse response. 0.47. What is the ratio of the Amount (in current US$) of Morocco in 1981 to that in 1986?
Keep it short and to the point. 0.61. What is the ratio of the Amount (in current US$) of Philippines in 1981 to that in 1986?
Offer a terse response. 3.99. What is the ratio of the Amount (in current US$) in Djibouti in 1982 to that in 1983?
Make the answer very short. 0.56. What is the ratio of the Amount (in current US$) in Guinea in 1982 to that in 1983?
Ensure brevity in your answer.  0.84. What is the ratio of the Amount (in current US$) of Morocco in 1982 to that in 1983?
Offer a terse response. 0.8. What is the ratio of the Amount (in current US$) in Philippines in 1982 to that in 1983?
Your answer should be compact. 0.42. What is the ratio of the Amount (in current US$) in Djibouti in 1982 to that in 1984?
Ensure brevity in your answer.  0.25. What is the ratio of the Amount (in current US$) of Guinea in 1982 to that in 1984?
Your response must be concise. 0.66. What is the ratio of the Amount (in current US$) of Morocco in 1982 to that in 1984?
Ensure brevity in your answer.  0.85. What is the ratio of the Amount (in current US$) of Philippines in 1982 to that in 1984?
Make the answer very short. 0.81. What is the ratio of the Amount (in current US$) of Djibouti in 1982 to that in 1985?
Provide a short and direct response. 0.18. What is the ratio of the Amount (in current US$) of Guinea in 1982 to that in 1985?
Your answer should be compact. 0.96. What is the ratio of the Amount (in current US$) in Morocco in 1982 to that in 1985?
Offer a terse response. 0.61. What is the ratio of the Amount (in current US$) of Philippines in 1982 to that in 1985?
Your response must be concise. 1.22. What is the ratio of the Amount (in current US$) of Djibouti in 1982 to that in 1986?
Offer a very short reply. 0.19. What is the ratio of the Amount (in current US$) of Guinea in 1982 to that in 1986?
Your answer should be very brief. 0.3. What is the ratio of the Amount (in current US$) of Morocco in 1982 to that in 1986?
Offer a terse response. 0.55. What is the ratio of the Amount (in current US$) of Philippines in 1982 to that in 1986?
Offer a very short reply. 2.32. What is the ratio of the Amount (in current US$) of Djibouti in 1983 to that in 1984?
Provide a short and direct response. 0.45. What is the ratio of the Amount (in current US$) in Guinea in 1983 to that in 1984?
Your answer should be compact. 0.79. What is the ratio of the Amount (in current US$) of Morocco in 1983 to that in 1984?
Provide a succinct answer. 1.07. What is the ratio of the Amount (in current US$) of Philippines in 1983 to that in 1984?
Your answer should be very brief. 1.91. What is the ratio of the Amount (in current US$) in Djibouti in 1983 to that in 1985?
Ensure brevity in your answer.  0.32. What is the ratio of the Amount (in current US$) of Guinea in 1983 to that in 1985?
Ensure brevity in your answer.  1.15. What is the ratio of the Amount (in current US$) of Morocco in 1983 to that in 1985?
Keep it short and to the point. 0.76. What is the ratio of the Amount (in current US$) of Philippines in 1983 to that in 1985?
Provide a short and direct response. 2.88. What is the ratio of the Amount (in current US$) of Djibouti in 1983 to that in 1986?
Keep it short and to the point. 0.34. What is the ratio of the Amount (in current US$) in Guinea in 1983 to that in 1986?
Give a very brief answer. 0.36. What is the ratio of the Amount (in current US$) of Morocco in 1983 to that in 1986?
Provide a short and direct response. 0.69. What is the ratio of the Amount (in current US$) of Philippines in 1983 to that in 1986?
Your answer should be very brief. 5.46. What is the ratio of the Amount (in current US$) of Djibouti in 1984 to that in 1985?
Ensure brevity in your answer.  0.72. What is the ratio of the Amount (in current US$) in Guinea in 1984 to that in 1985?
Give a very brief answer. 1.45. What is the ratio of the Amount (in current US$) in Morocco in 1984 to that in 1985?
Your response must be concise. 0.71. What is the ratio of the Amount (in current US$) of Philippines in 1984 to that in 1985?
Your response must be concise. 1.51. What is the ratio of the Amount (in current US$) of Djibouti in 1984 to that in 1986?
Your answer should be very brief. 0.76. What is the ratio of the Amount (in current US$) of Guinea in 1984 to that in 1986?
Ensure brevity in your answer.  0.45. What is the ratio of the Amount (in current US$) in Morocco in 1984 to that in 1986?
Offer a very short reply. 0.65. What is the ratio of the Amount (in current US$) in Philippines in 1984 to that in 1986?
Offer a terse response. 2.86. What is the ratio of the Amount (in current US$) of Djibouti in 1985 to that in 1986?
Offer a very short reply. 1.05. What is the ratio of the Amount (in current US$) of Guinea in 1985 to that in 1986?
Provide a succinct answer. 0.31. What is the ratio of the Amount (in current US$) in Morocco in 1985 to that in 1986?
Keep it short and to the point. 0.91. What is the ratio of the Amount (in current US$) in Philippines in 1985 to that in 1986?
Your answer should be compact. 1.9. What is the difference between the highest and the second highest Amount (in current US$) in Djibouti?
Make the answer very short. 5.93e+05. What is the difference between the highest and the second highest Amount (in current US$) of Guinea?
Make the answer very short. 3.14e+07. What is the difference between the highest and the second highest Amount (in current US$) in Morocco?
Your response must be concise. 3.01e+07. What is the difference between the highest and the second highest Amount (in current US$) of Philippines?
Ensure brevity in your answer.  1.92e+08. What is the difference between the highest and the lowest Amount (in current US$) of Djibouti?
Your answer should be compact. 1.28e+07. What is the difference between the highest and the lowest Amount (in current US$) of Guinea?
Offer a very short reply. 4.18e+07. What is the difference between the highest and the lowest Amount (in current US$) of Morocco?
Offer a terse response. 2.69e+08. What is the difference between the highest and the lowest Amount (in current US$) of Philippines?
Offer a terse response. 5.82e+08. 